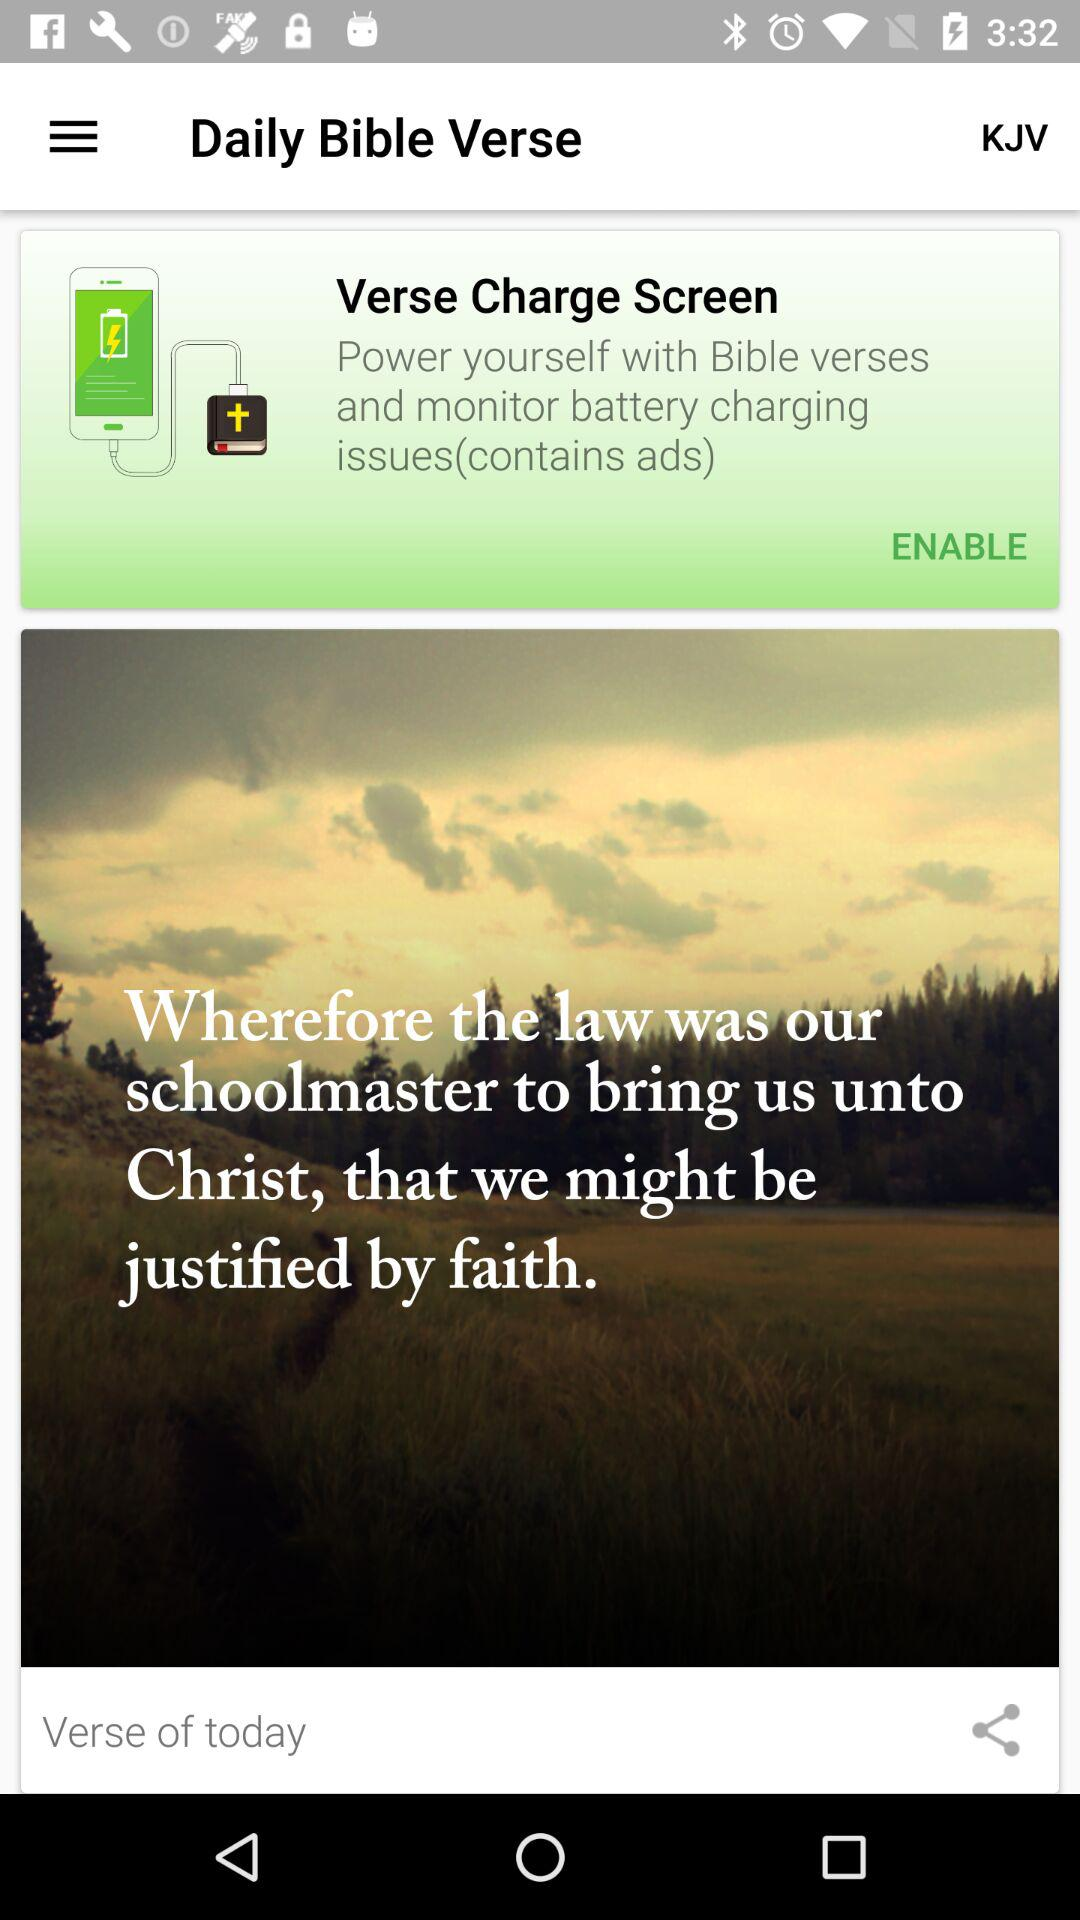How many past Bible verses are available?
When the provided information is insufficient, respond with <no answer>. <no answer> 